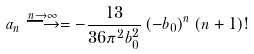<formula> <loc_0><loc_0><loc_500><loc_500>a _ { n } \stackrel { n \rightarrow \infty } { \longrightarrow } = - { \frac { 1 3 } { 3 6 \pi ^ { 2 } b _ { 0 } ^ { 2 } } } \left ( - b _ { 0 } \right ) ^ { n } ( n + 1 ) !</formula> 